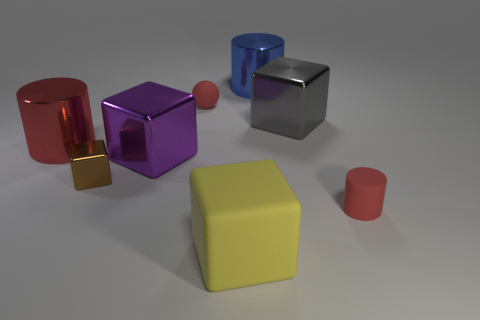Subtract 1 blocks. How many blocks are left? 3 Add 2 blue rubber cylinders. How many objects exist? 10 Subtract all balls. How many objects are left? 7 Subtract 1 purple blocks. How many objects are left? 7 Subtract all blue cylinders. Subtract all big red metallic cylinders. How many objects are left? 6 Add 8 blue cylinders. How many blue cylinders are left? 9 Add 3 tiny cylinders. How many tiny cylinders exist? 4 